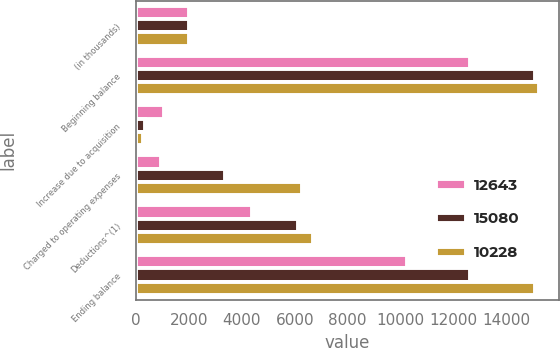<chart> <loc_0><loc_0><loc_500><loc_500><stacked_bar_chart><ecel><fcel>(in thousands)<fcel>Beginning balance<fcel>Increase due to acquisition<fcel>Charged to operating expenses<fcel>Deductions^(1)<fcel>Ending balance<nl><fcel>12643<fcel>2013<fcel>12643<fcel>1038<fcel>933<fcel>4386<fcel>10228<nl><fcel>15080<fcel>2012<fcel>15080<fcel>325<fcel>3356<fcel>6118<fcel>12643<nl><fcel>10228<fcel>2011<fcel>15233<fcel>269<fcel>6271<fcel>6693<fcel>15080<nl></chart> 